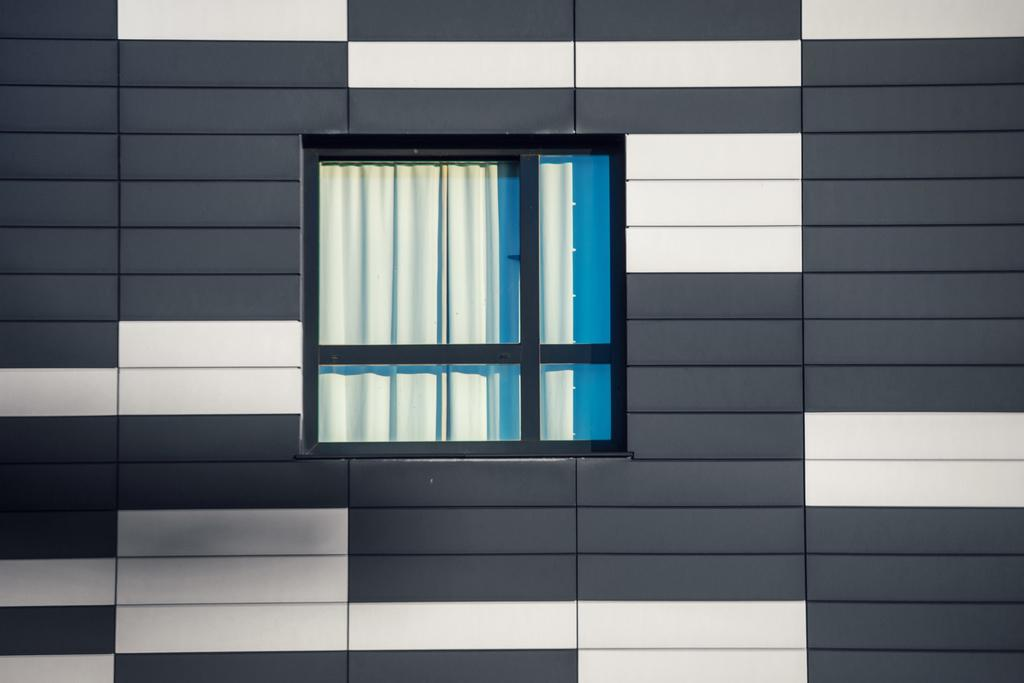What is a prominent feature in the picture? There is a wall in the picture. What is a notable detail about the wall? The wall has a window. What color scheme is used for the wall in the picture? The wall is black and white in color. How does the stomach of the person in the picture feel? There is no person present in the picture, so we cannot determine how their stomach feels. 